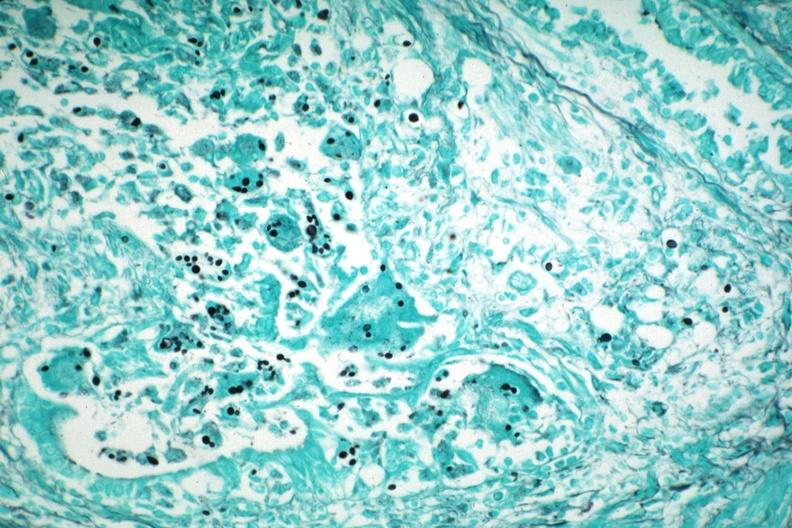what does gms illustrate?
Answer the question using a single word or phrase. Organisms granulomatous prostatitis aids case 